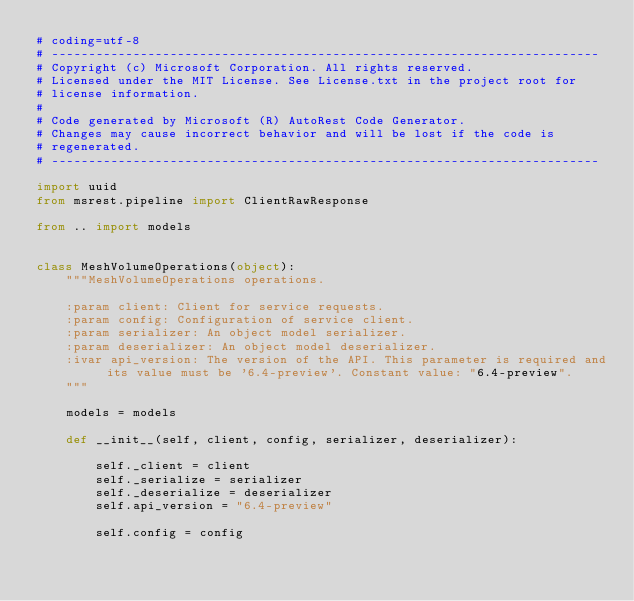<code> <loc_0><loc_0><loc_500><loc_500><_Python_># coding=utf-8
# --------------------------------------------------------------------------
# Copyright (c) Microsoft Corporation. All rights reserved.
# Licensed under the MIT License. See License.txt in the project root for
# license information.
#
# Code generated by Microsoft (R) AutoRest Code Generator.
# Changes may cause incorrect behavior and will be lost if the code is
# regenerated.
# --------------------------------------------------------------------------

import uuid
from msrest.pipeline import ClientRawResponse

from .. import models


class MeshVolumeOperations(object):
    """MeshVolumeOperations operations.

    :param client: Client for service requests.
    :param config: Configuration of service client.
    :param serializer: An object model serializer.
    :param deserializer: An object model deserializer.
    :ivar api_version: The version of the API. This parameter is required and its value must be '6.4-preview'. Constant value: "6.4-preview".
    """

    models = models

    def __init__(self, client, config, serializer, deserializer):

        self._client = client
        self._serialize = serializer
        self._deserialize = deserializer
        self.api_version = "6.4-preview"

        self.config = config
</code> 